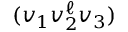Convert formula to latex. <formula><loc_0><loc_0><loc_500><loc_500>( v _ { 1 } v _ { 2 } ^ { \ell } v _ { 3 } )</formula> 